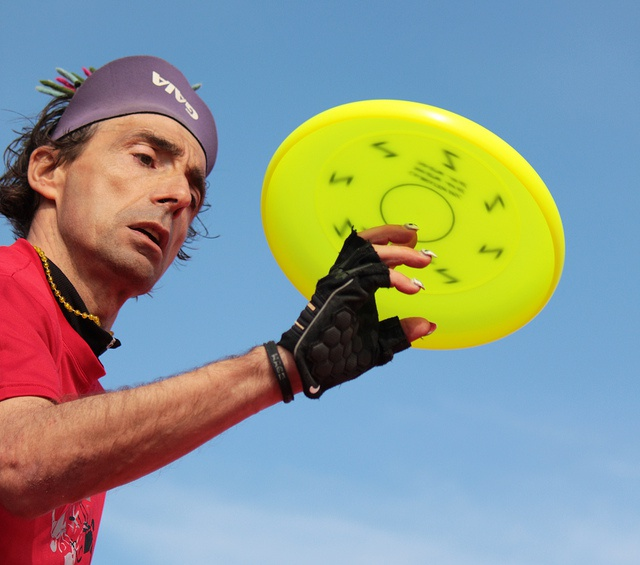Describe the objects in this image and their specific colors. I can see people in gray, black, maroon, tan, and brown tones and frisbee in gray, yellow, khaki, and gold tones in this image. 